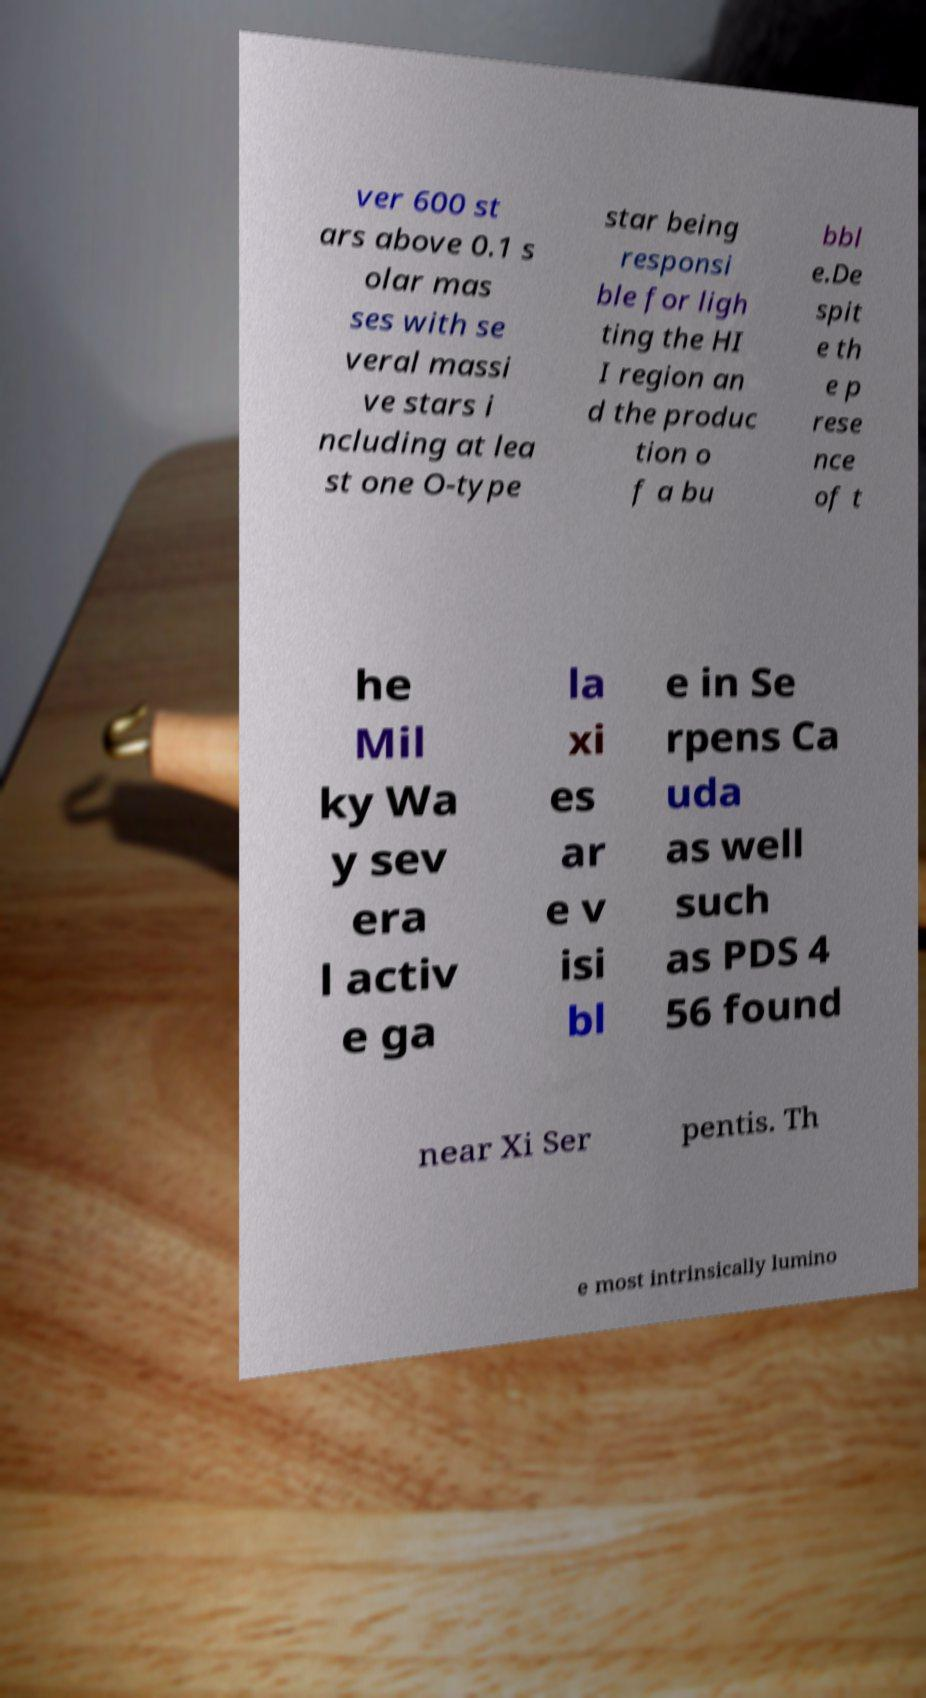Please identify and transcribe the text found in this image. ver 600 st ars above 0.1 s olar mas ses with se veral massi ve stars i ncluding at lea st one O-type star being responsi ble for ligh ting the HI I region an d the produc tion o f a bu bbl e.De spit e th e p rese nce of t he Mil ky Wa y sev era l activ e ga la xi es ar e v isi bl e in Se rpens Ca uda as well such as PDS 4 56 found near Xi Ser pentis. Th e most intrinsically lumino 